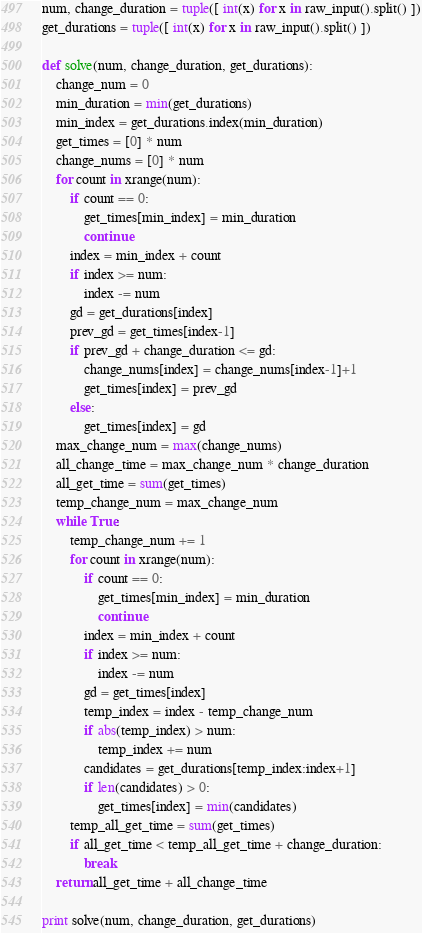Convert code to text. <code><loc_0><loc_0><loc_500><loc_500><_Python_>num, change_duration = tuple([ int(x) for x in raw_input().split() ])
get_durations = tuple([ int(x) for x in raw_input().split() ])

def solve(num, change_duration, get_durations):
    change_num = 0
    min_duration = min(get_durations)
    min_index = get_durations.index(min_duration)
    get_times = [0] * num
    change_nums = [0] * num
    for count in xrange(num):
        if count == 0:
            get_times[min_index] = min_duration
            continue
        index = min_index + count
        if index >= num:
            index -= num
        gd = get_durations[index]
        prev_gd = get_times[index-1]
        if prev_gd + change_duration <= gd:
            change_nums[index] = change_nums[index-1]+1
            get_times[index] = prev_gd
        else:
            get_times[index] = gd
    max_change_num = max(change_nums)
    all_change_time = max_change_num * change_duration
    all_get_time = sum(get_times)
    temp_change_num = max_change_num
    while True:
        temp_change_num += 1
        for count in xrange(num):
            if count == 0:
                get_times[min_index] = min_duration
                continue
            index = min_index + count
            if index >= num:
                index -= num
            gd = get_times[index]
            temp_index = index - temp_change_num
            if abs(temp_index) > num:
                temp_index += num
            candidates = get_durations[temp_index:index+1]
            if len(candidates) > 0:
                get_times[index] = min(candidates)
        temp_all_get_time = sum(get_times)
        if all_get_time < temp_all_get_time + change_duration:
            break
    return all_get_time + all_change_time

print solve(num, change_duration, get_durations)
</code> 